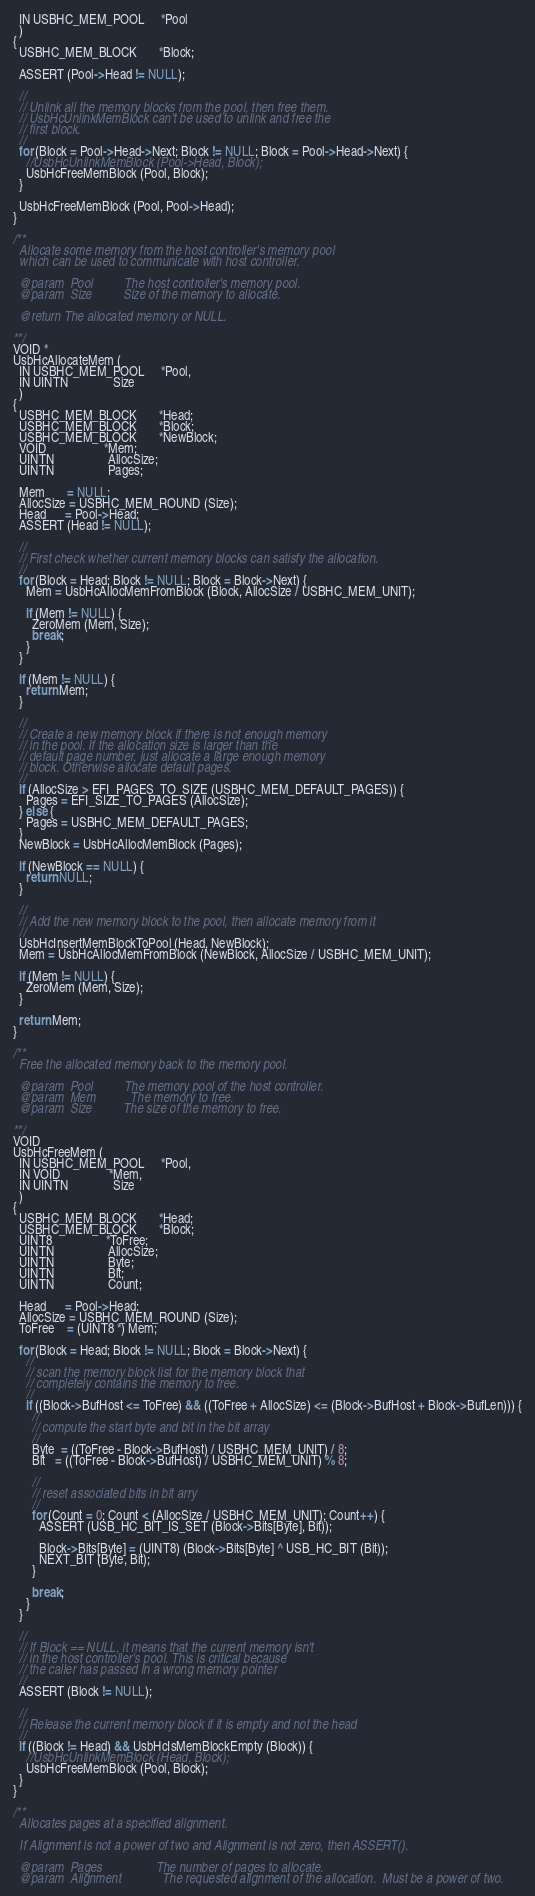<code> <loc_0><loc_0><loc_500><loc_500><_C_>  IN USBHC_MEM_POOL     *Pool
  )
{
  USBHC_MEM_BLOCK       *Block;

  ASSERT (Pool->Head != NULL);

  //
  // Unlink all the memory blocks from the pool, then free them.
  // UsbHcUnlinkMemBlock can't be used to unlink and free the
  // first block.
  //
  for (Block = Pool->Head->Next; Block != NULL; Block = Pool->Head->Next) {
    //UsbHcUnlinkMemBlock (Pool->Head, Block);
    UsbHcFreeMemBlock (Pool, Block);
  }

  UsbHcFreeMemBlock (Pool, Pool->Head);
}

/**
  Allocate some memory from the host controller's memory pool
  which can be used to communicate with host controller.

  @param  Pool          The host controller's memory pool.
  @param  Size          Size of the memory to allocate.

  @return The allocated memory or NULL.

**/
VOID *
UsbHcAllocateMem (
  IN USBHC_MEM_POOL     *Pool,
  IN UINTN              Size
  )
{
  USBHC_MEM_BLOCK       *Head;
  USBHC_MEM_BLOCK       *Block;
  USBHC_MEM_BLOCK       *NewBlock;
  VOID                  *Mem;
  UINTN                 AllocSize;
  UINTN                 Pages;

  Mem       = NULL;
  AllocSize = USBHC_MEM_ROUND (Size);
  Head      = Pool->Head;
  ASSERT (Head != NULL);

  //
  // First check whether current memory blocks can satisfy the allocation.
  //
  for (Block = Head; Block != NULL; Block = Block->Next) {
    Mem = UsbHcAllocMemFromBlock (Block, AllocSize / USBHC_MEM_UNIT);

    if (Mem != NULL) {
      ZeroMem (Mem, Size);
      break;
    }
  }

  if (Mem != NULL) {
    return Mem;
  }

  //
  // Create a new memory block if there is not enough memory
  // in the pool. If the allocation size is larger than the
  // default page number, just allocate a large enough memory
  // block. Otherwise allocate default pages.
  //
  if (AllocSize > EFI_PAGES_TO_SIZE (USBHC_MEM_DEFAULT_PAGES)) {
    Pages = EFI_SIZE_TO_PAGES (AllocSize);
  } else {
    Pages = USBHC_MEM_DEFAULT_PAGES;
  }
  NewBlock = UsbHcAllocMemBlock (Pages);

  if (NewBlock == NULL) {
    return NULL;
  }

  //
  // Add the new memory block to the pool, then allocate memory from it
  //
  UsbHcInsertMemBlockToPool (Head, NewBlock);
  Mem = UsbHcAllocMemFromBlock (NewBlock, AllocSize / USBHC_MEM_UNIT);

  if (Mem != NULL) {
    ZeroMem (Mem, Size);
  }

  return Mem;
}

/**
  Free the allocated memory back to the memory pool.

  @param  Pool          The memory pool of the host controller.
  @param  Mem           The memory to free.
  @param  Size          The size of the memory to free.

**/
VOID
UsbHcFreeMem (
  IN USBHC_MEM_POOL     *Pool,
  IN VOID               *Mem,
  IN UINTN              Size
  )
{
  USBHC_MEM_BLOCK       *Head;
  USBHC_MEM_BLOCK       *Block;
  UINT8                 *ToFree;
  UINTN                 AllocSize;
  UINTN                 Byte;
  UINTN                 Bit;
  UINTN                 Count;

  Head      = Pool->Head;
  AllocSize = USBHC_MEM_ROUND (Size);
  ToFree    = (UINT8 *) Mem;

  for (Block = Head; Block != NULL; Block = Block->Next) {
    //
    // scan the memory block list for the memory block that
    // completely contains the memory to free.
    //
    if ((Block->BufHost <= ToFree) && ((ToFree + AllocSize) <= (Block->BufHost + Block->BufLen))) {
      //
      // compute the start byte and bit in the bit array
      //
      Byte  = ((ToFree - Block->BufHost) / USBHC_MEM_UNIT) / 8;
      Bit   = ((ToFree - Block->BufHost) / USBHC_MEM_UNIT) % 8;

      //
      // reset associated bits in bit arry
      //
      for (Count = 0; Count < (AllocSize / USBHC_MEM_UNIT); Count++) {
        ASSERT (USB_HC_BIT_IS_SET (Block->Bits[Byte], Bit));

        Block->Bits[Byte] = (UINT8) (Block->Bits[Byte] ^ USB_HC_BIT (Bit));
        NEXT_BIT (Byte, Bit);
      }

      break;
    }
  }

  //
  // If Block == NULL, it means that the current memory isn't
  // in the host controller's pool. This is critical because
  // the caller has passed in a wrong memory pointer
  //
  ASSERT (Block != NULL);

  //
  // Release the current memory block if it is empty and not the head
  //
  if ((Block != Head) && UsbHcIsMemBlockEmpty (Block)) {
    //UsbHcUnlinkMemBlock (Head, Block);
    UsbHcFreeMemBlock (Pool, Block);
  }
}

/**
  Allocates pages at a specified alignment.

  If Alignment is not a power of two and Alignment is not zero, then ASSERT().

  @param  Pages                 The number of pages to allocate.
  @param  Alignment             The requested alignment of the allocation.  Must be a power of two.</code> 